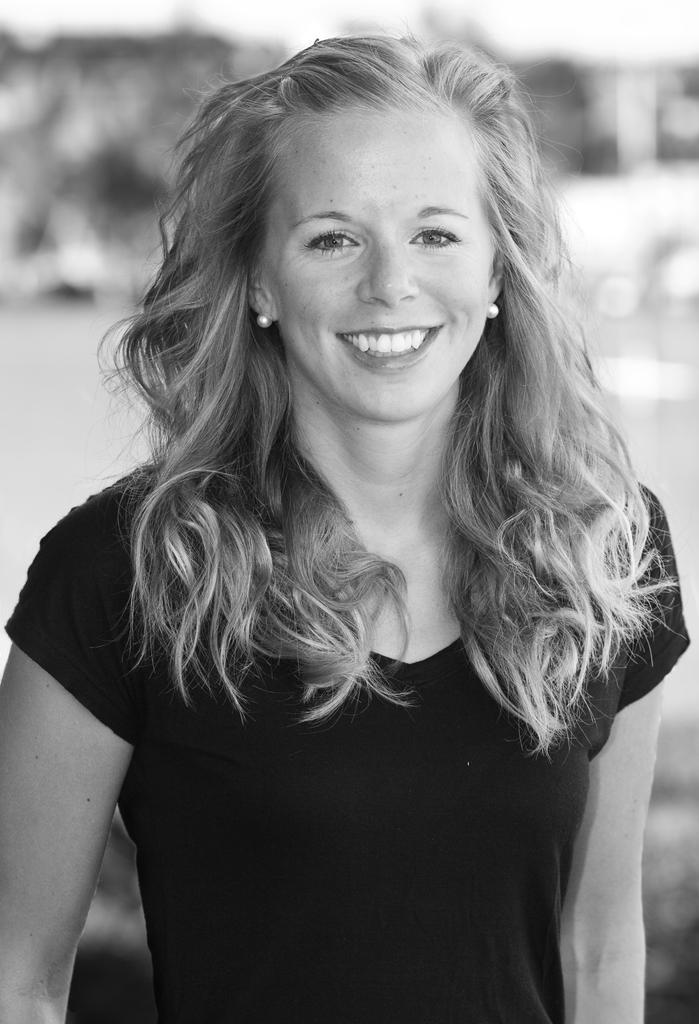How would you summarize this image in a sentence or two? In the middle of the image a woman is standing and smiling. Background of the image is blur. 